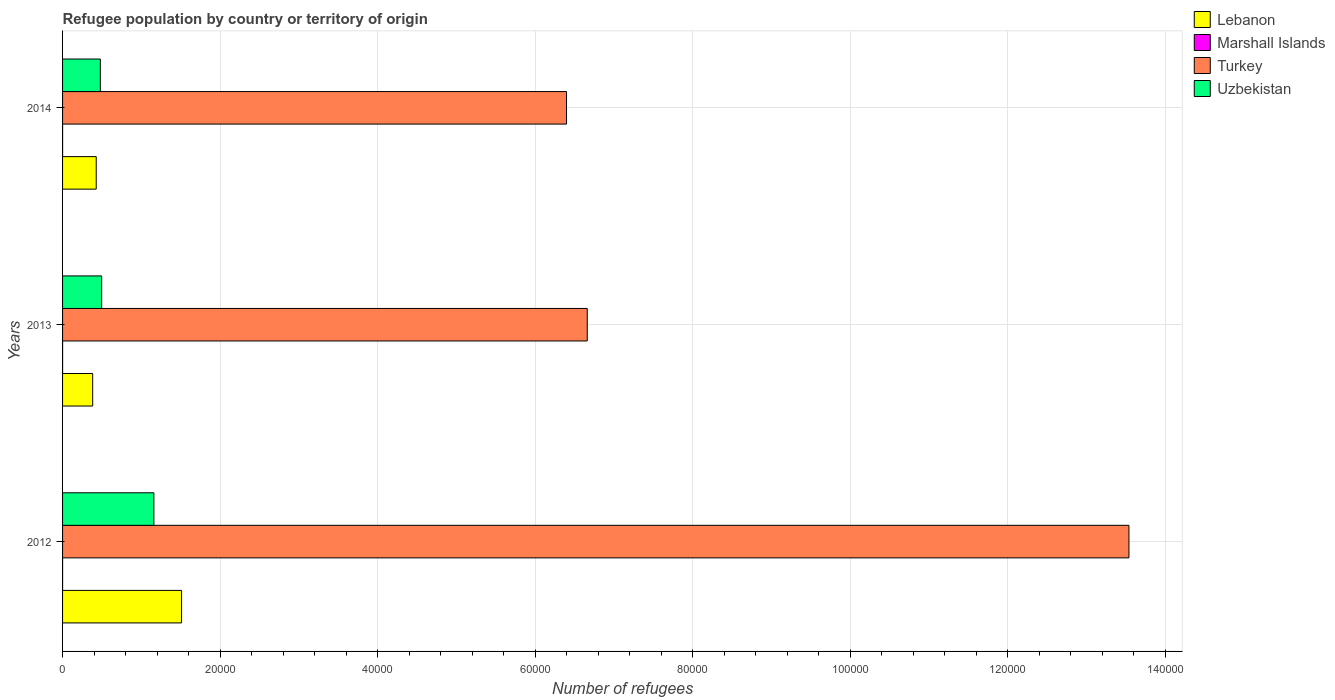How many different coloured bars are there?
Your response must be concise. 4. Are the number of bars per tick equal to the number of legend labels?
Make the answer very short. Yes. How many bars are there on the 2nd tick from the top?
Give a very brief answer. 4. In how many cases, is the number of bars for a given year not equal to the number of legend labels?
Give a very brief answer. 0. What is the number of refugees in Turkey in 2014?
Make the answer very short. 6.40e+04. Across all years, what is the maximum number of refugees in Turkey?
Offer a terse response. 1.35e+05. Across all years, what is the minimum number of refugees in Uzbekistan?
Offer a very short reply. 4796. In which year was the number of refugees in Marshall Islands minimum?
Provide a succinct answer. 2012. What is the difference between the number of refugees in Marshall Islands in 2012 and that in 2014?
Offer a very short reply. -1. What is the difference between the number of refugees in Uzbekistan in 2014 and the number of refugees in Turkey in 2013?
Your answer should be very brief. -6.18e+04. What is the average number of refugees in Lebanon per year?
Your answer should be compact. 7734. In the year 2014, what is the difference between the number of refugees in Marshall Islands and number of refugees in Uzbekistan?
Provide a succinct answer. -4793. What is the ratio of the number of refugees in Turkey in 2012 to that in 2013?
Your answer should be compact. 2.03. Is the number of refugees in Turkey in 2012 less than that in 2014?
Keep it short and to the point. No. Is the difference between the number of refugees in Marshall Islands in 2012 and 2014 greater than the difference between the number of refugees in Uzbekistan in 2012 and 2014?
Your response must be concise. No. What is the difference between the highest and the lowest number of refugees in Turkey?
Offer a terse response. 7.14e+04. In how many years, is the number of refugees in Marshall Islands greater than the average number of refugees in Marshall Islands taken over all years?
Your answer should be very brief. 2. What does the 3rd bar from the top in 2012 represents?
Your answer should be very brief. Marshall Islands. What does the 2nd bar from the bottom in 2012 represents?
Ensure brevity in your answer.  Marshall Islands. Is it the case that in every year, the sum of the number of refugees in Turkey and number of refugees in Uzbekistan is greater than the number of refugees in Lebanon?
Your answer should be compact. Yes. How many bars are there?
Give a very brief answer. 12. Are all the bars in the graph horizontal?
Ensure brevity in your answer.  Yes. Does the graph contain grids?
Give a very brief answer. Yes. How are the legend labels stacked?
Offer a very short reply. Vertical. What is the title of the graph?
Provide a succinct answer. Refugee population by country or territory of origin. Does "Uruguay" appear as one of the legend labels in the graph?
Provide a short and direct response. No. What is the label or title of the X-axis?
Your answer should be compact. Number of refugees. What is the Number of refugees in Lebanon in 2012?
Offer a terse response. 1.51e+04. What is the Number of refugees in Marshall Islands in 2012?
Keep it short and to the point. 2. What is the Number of refugees in Turkey in 2012?
Your answer should be very brief. 1.35e+05. What is the Number of refugees in Uzbekistan in 2012?
Provide a short and direct response. 1.16e+04. What is the Number of refugees in Lebanon in 2013?
Provide a succinct answer. 3824. What is the Number of refugees of Turkey in 2013?
Make the answer very short. 6.66e+04. What is the Number of refugees in Uzbekistan in 2013?
Your answer should be compact. 4965. What is the Number of refugees of Lebanon in 2014?
Make the answer very short. 4272. What is the Number of refugees of Marshall Islands in 2014?
Give a very brief answer. 3. What is the Number of refugees in Turkey in 2014?
Provide a succinct answer. 6.40e+04. What is the Number of refugees in Uzbekistan in 2014?
Make the answer very short. 4796. Across all years, what is the maximum Number of refugees in Lebanon?
Make the answer very short. 1.51e+04. Across all years, what is the maximum Number of refugees of Marshall Islands?
Provide a succinct answer. 3. Across all years, what is the maximum Number of refugees in Turkey?
Make the answer very short. 1.35e+05. Across all years, what is the maximum Number of refugees of Uzbekistan?
Your response must be concise. 1.16e+04. Across all years, what is the minimum Number of refugees in Lebanon?
Give a very brief answer. 3824. Across all years, what is the minimum Number of refugees of Marshall Islands?
Provide a short and direct response. 2. Across all years, what is the minimum Number of refugees of Turkey?
Ensure brevity in your answer.  6.40e+04. Across all years, what is the minimum Number of refugees in Uzbekistan?
Provide a short and direct response. 4796. What is the total Number of refugees of Lebanon in the graph?
Offer a very short reply. 2.32e+04. What is the total Number of refugees in Turkey in the graph?
Make the answer very short. 2.66e+05. What is the total Number of refugees of Uzbekistan in the graph?
Your answer should be compact. 2.14e+04. What is the difference between the Number of refugees in Lebanon in 2012 and that in 2013?
Your answer should be compact. 1.13e+04. What is the difference between the Number of refugees in Turkey in 2012 and that in 2013?
Ensure brevity in your answer.  6.88e+04. What is the difference between the Number of refugees in Uzbekistan in 2012 and that in 2013?
Make the answer very short. 6628. What is the difference between the Number of refugees of Lebanon in 2012 and that in 2014?
Provide a succinct answer. 1.08e+04. What is the difference between the Number of refugees in Marshall Islands in 2012 and that in 2014?
Keep it short and to the point. -1. What is the difference between the Number of refugees in Turkey in 2012 and that in 2014?
Ensure brevity in your answer.  7.14e+04. What is the difference between the Number of refugees of Uzbekistan in 2012 and that in 2014?
Provide a succinct answer. 6797. What is the difference between the Number of refugees in Lebanon in 2013 and that in 2014?
Ensure brevity in your answer.  -448. What is the difference between the Number of refugees of Marshall Islands in 2013 and that in 2014?
Provide a short and direct response. 0. What is the difference between the Number of refugees in Turkey in 2013 and that in 2014?
Provide a succinct answer. 2632. What is the difference between the Number of refugees of Uzbekistan in 2013 and that in 2014?
Give a very brief answer. 169. What is the difference between the Number of refugees in Lebanon in 2012 and the Number of refugees in Marshall Islands in 2013?
Make the answer very short. 1.51e+04. What is the difference between the Number of refugees in Lebanon in 2012 and the Number of refugees in Turkey in 2013?
Offer a terse response. -5.15e+04. What is the difference between the Number of refugees in Lebanon in 2012 and the Number of refugees in Uzbekistan in 2013?
Your response must be concise. 1.01e+04. What is the difference between the Number of refugees in Marshall Islands in 2012 and the Number of refugees in Turkey in 2013?
Give a very brief answer. -6.66e+04. What is the difference between the Number of refugees of Marshall Islands in 2012 and the Number of refugees of Uzbekistan in 2013?
Give a very brief answer. -4963. What is the difference between the Number of refugees in Turkey in 2012 and the Number of refugees in Uzbekistan in 2013?
Keep it short and to the point. 1.30e+05. What is the difference between the Number of refugees in Lebanon in 2012 and the Number of refugees in Marshall Islands in 2014?
Ensure brevity in your answer.  1.51e+04. What is the difference between the Number of refugees in Lebanon in 2012 and the Number of refugees in Turkey in 2014?
Give a very brief answer. -4.89e+04. What is the difference between the Number of refugees in Lebanon in 2012 and the Number of refugees in Uzbekistan in 2014?
Provide a short and direct response. 1.03e+04. What is the difference between the Number of refugees of Marshall Islands in 2012 and the Number of refugees of Turkey in 2014?
Your answer should be compact. -6.40e+04. What is the difference between the Number of refugees in Marshall Islands in 2012 and the Number of refugees in Uzbekistan in 2014?
Provide a succinct answer. -4794. What is the difference between the Number of refugees of Turkey in 2012 and the Number of refugees of Uzbekistan in 2014?
Provide a succinct answer. 1.31e+05. What is the difference between the Number of refugees of Lebanon in 2013 and the Number of refugees of Marshall Islands in 2014?
Give a very brief answer. 3821. What is the difference between the Number of refugees of Lebanon in 2013 and the Number of refugees of Turkey in 2014?
Ensure brevity in your answer.  -6.02e+04. What is the difference between the Number of refugees in Lebanon in 2013 and the Number of refugees in Uzbekistan in 2014?
Offer a very short reply. -972. What is the difference between the Number of refugees of Marshall Islands in 2013 and the Number of refugees of Turkey in 2014?
Offer a very short reply. -6.40e+04. What is the difference between the Number of refugees in Marshall Islands in 2013 and the Number of refugees in Uzbekistan in 2014?
Offer a very short reply. -4793. What is the difference between the Number of refugees of Turkey in 2013 and the Number of refugees of Uzbekistan in 2014?
Provide a short and direct response. 6.18e+04. What is the average Number of refugees in Lebanon per year?
Give a very brief answer. 7734. What is the average Number of refugees in Marshall Islands per year?
Ensure brevity in your answer.  2.67. What is the average Number of refugees of Turkey per year?
Your answer should be compact. 8.87e+04. What is the average Number of refugees of Uzbekistan per year?
Make the answer very short. 7118. In the year 2012, what is the difference between the Number of refugees in Lebanon and Number of refugees in Marshall Islands?
Make the answer very short. 1.51e+04. In the year 2012, what is the difference between the Number of refugees in Lebanon and Number of refugees in Turkey?
Make the answer very short. -1.20e+05. In the year 2012, what is the difference between the Number of refugees of Lebanon and Number of refugees of Uzbekistan?
Offer a terse response. 3513. In the year 2012, what is the difference between the Number of refugees in Marshall Islands and Number of refugees in Turkey?
Your response must be concise. -1.35e+05. In the year 2012, what is the difference between the Number of refugees in Marshall Islands and Number of refugees in Uzbekistan?
Keep it short and to the point. -1.16e+04. In the year 2012, what is the difference between the Number of refugees of Turkey and Number of refugees of Uzbekistan?
Provide a short and direct response. 1.24e+05. In the year 2013, what is the difference between the Number of refugees of Lebanon and Number of refugees of Marshall Islands?
Offer a terse response. 3821. In the year 2013, what is the difference between the Number of refugees of Lebanon and Number of refugees of Turkey?
Provide a short and direct response. -6.28e+04. In the year 2013, what is the difference between the Number of refugees in Lebanon and Number of refugees in Uzbekistan?
Your response must be concise. -1141. In the year 2013, what is the difference between the Number of refugees in Marshall Islands and Number of refugees in Turkey?
Your response must be concise. -6.66e+04. In the year 2013, what is the difference between the Number of refugees of Marshall Islands and Number of refugees of Uzbekistan?
Provide a short and direct response. -4962. In the year 2013, what is the difference between the Number of refugees in Turkey and Number of refugees in Uzbekistan?
Keep it short and to the point. 6.16e+04. In the year 2014, what is the difference between the Number of refugees of Lebanon and Number of refugees of Marshall Islands?
Provide a short and direct response. 4269. In the year 2014, what is the difference between the Number of refugees in Lebanon and Number of refugees in Turkey?
Offer a terse response. -5.97e+04. In the year 2014, what is the difference between the Number of refugees in Lebanon and Number of refugees in Uzbekistan?
Keep it short and to the point. -524. In the year 2014, what is the difference between the Number of refugees in Marshall Islands and Number of refugees in Turkey?
Make the answer very short. -6.40e+04. In the year 2014, what is the difference between the Number of refugees of Marshall Islands and Number of refugees of Uzbekistan?
Give a very brief answer. -4793. In the year 2014, what is the difference between the Number of refugees in Turkey and Number of refugees in Uzbekistan?
Your response must be concise. 5.92e+04. What is the ratio of the Number of refugees in Lebanon in 2012 to that in 2013?
Ensure brevity in your answer.  3.95. What is the ratio of the Number of refugees of Marshall Islands in 2012 to that in 2013?
Give a very brief answer. 0.67. What is the ratio of the Number of refugees of Turkey in 2012 to that in 2013?
Offer a very short reply. 2.03. What is the ratio of the Number of refugees of Uzbekistan in 2012 to that in 2013?
Make the answer very short. 2.33. What is the ratio of the Number of refugees in Lebanon in 2012 to that in 2014?
Your answer should be compact. 3.54. What is the ratio of the Number of refugees of Turkey in 2012 to that in 2014?
Provide a short and direct response. 2.12. What is the ratio of the Number of refugees of Uzbekistan in 2012 to that in 2014?
Your response must be concise. 2.42. What is the ratio of the Number of refugees of Lebanon in 2013 to that in 2014?
Your answer should be very brief. 0.9. What is the ratio of the Number of refugees in Turkey in 2013 to that in 2014?
Your answer should be very brief. 1.04. What is the ratio of the Number of refugees of Uzbekistan in 2013 to that in 2014?
Provide a succinct answer. 1.04. What is the difference between the highest and the second highest Number of refugees in Lebanon?
Provide a short and direct response. 1.08e+04. What is the difference between the highest and the second highest Number of refugees of Turkey?
Provide a short and direct response. 6.88e+04. What is the difference between the highest and the second highest Number of refugees in Uzbekistan?
Provide a short and direct response. 6628. What is the difference between the highest and the lowest Number of refugees of Lebanon?
Offer a very short reply. 1.13e+04. What is the difference between the highest and the lowest Number of refugees of Turkey?
Make the answer very short. 7.14e+04. What is the difference between the highest and the lowest Number of refugees in Uzbekistan?
Offer a very short reply. 6797. 